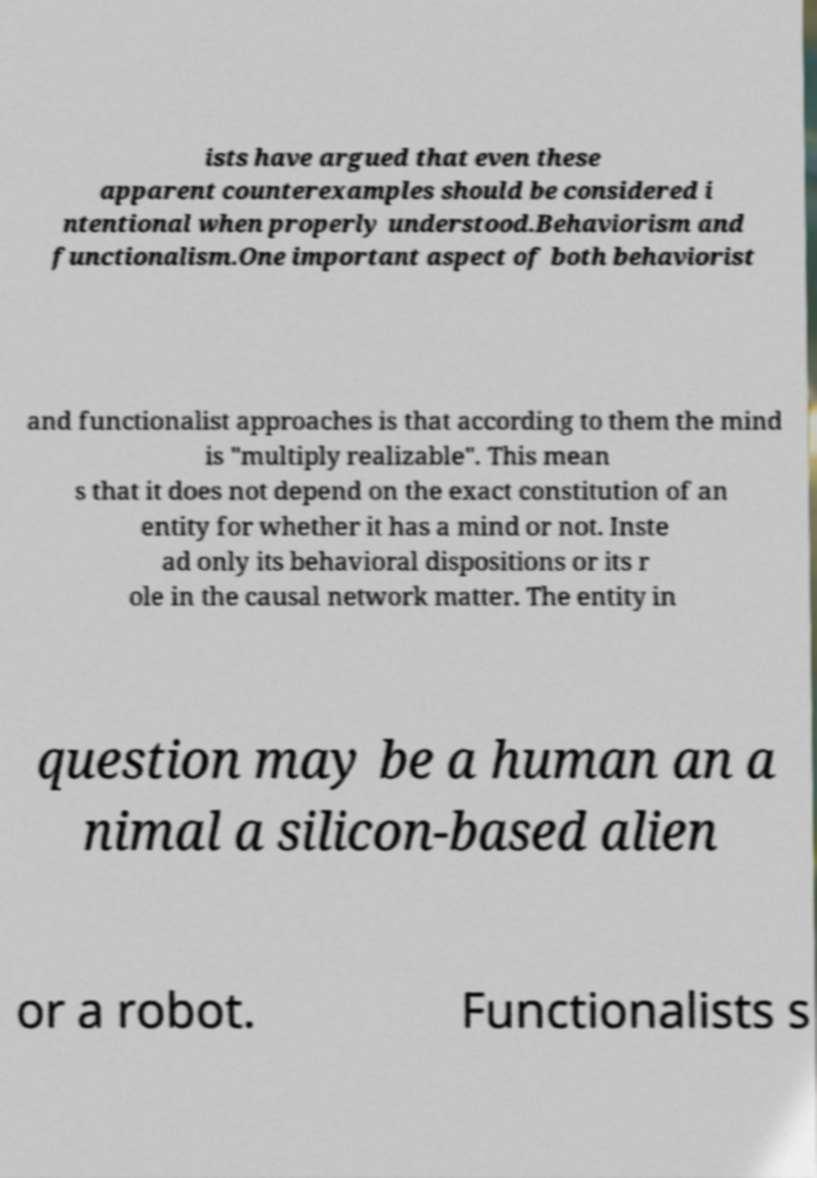I need the written content from this picture converted into text. Can you do that? ists have argued that even these apparent counterexamples should be considered i ntentional when properly understood.Behaviorism and functionalism.One important aspect of both behaviorist and functionalist approaches is that according to them the mind is "multiply realizable". This mean s that it does not depend on the exact constitution of an entity for whether it has a mind or not. Inste ad only its behavioral dispositions or its r ole in the causal network matter. The entity in question may be a human an a nimal a silicon-based alien or a robot. Functionalists s 